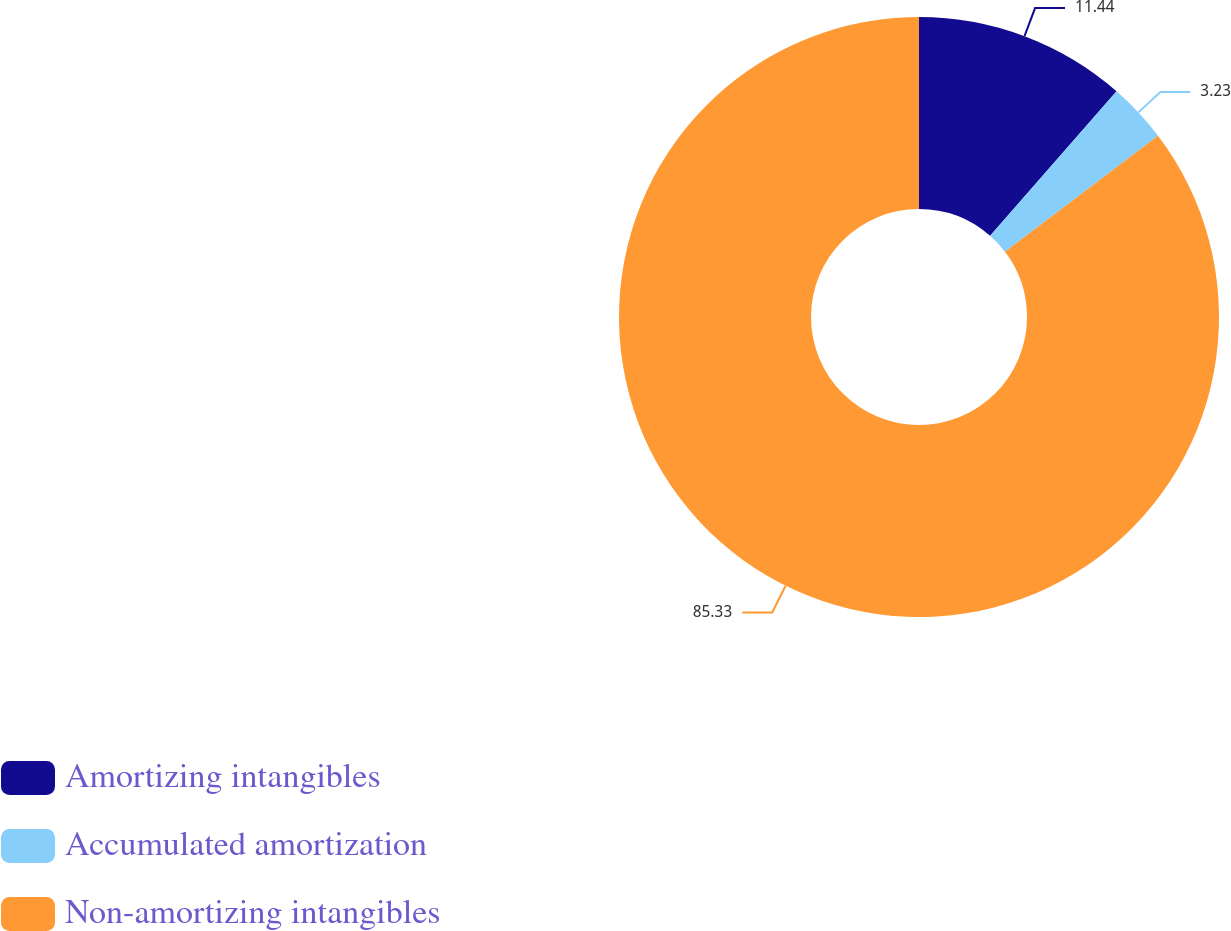Convert chart to OTSL. <chart><loc_0><loc_0><loc_500><loc_500><pie_chart><fcel>Amortizing intangibles<fcel>Accumulated amortization<fcel>Non-amortizing intangibles<nl><fcel>11.44%<fcel>3.23%<fcel>85.33%<nl></chart> 